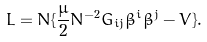Convert formula to latex. <formula><loc_0><loc_0><loc_500><loc_500>L = N \{ \frac { \mu } { 2 } N ^ { - 2 } G _ { i j } \dot { \beta } ^ { i } \dot { \beta } ^ { j } - V \} .</formula> 